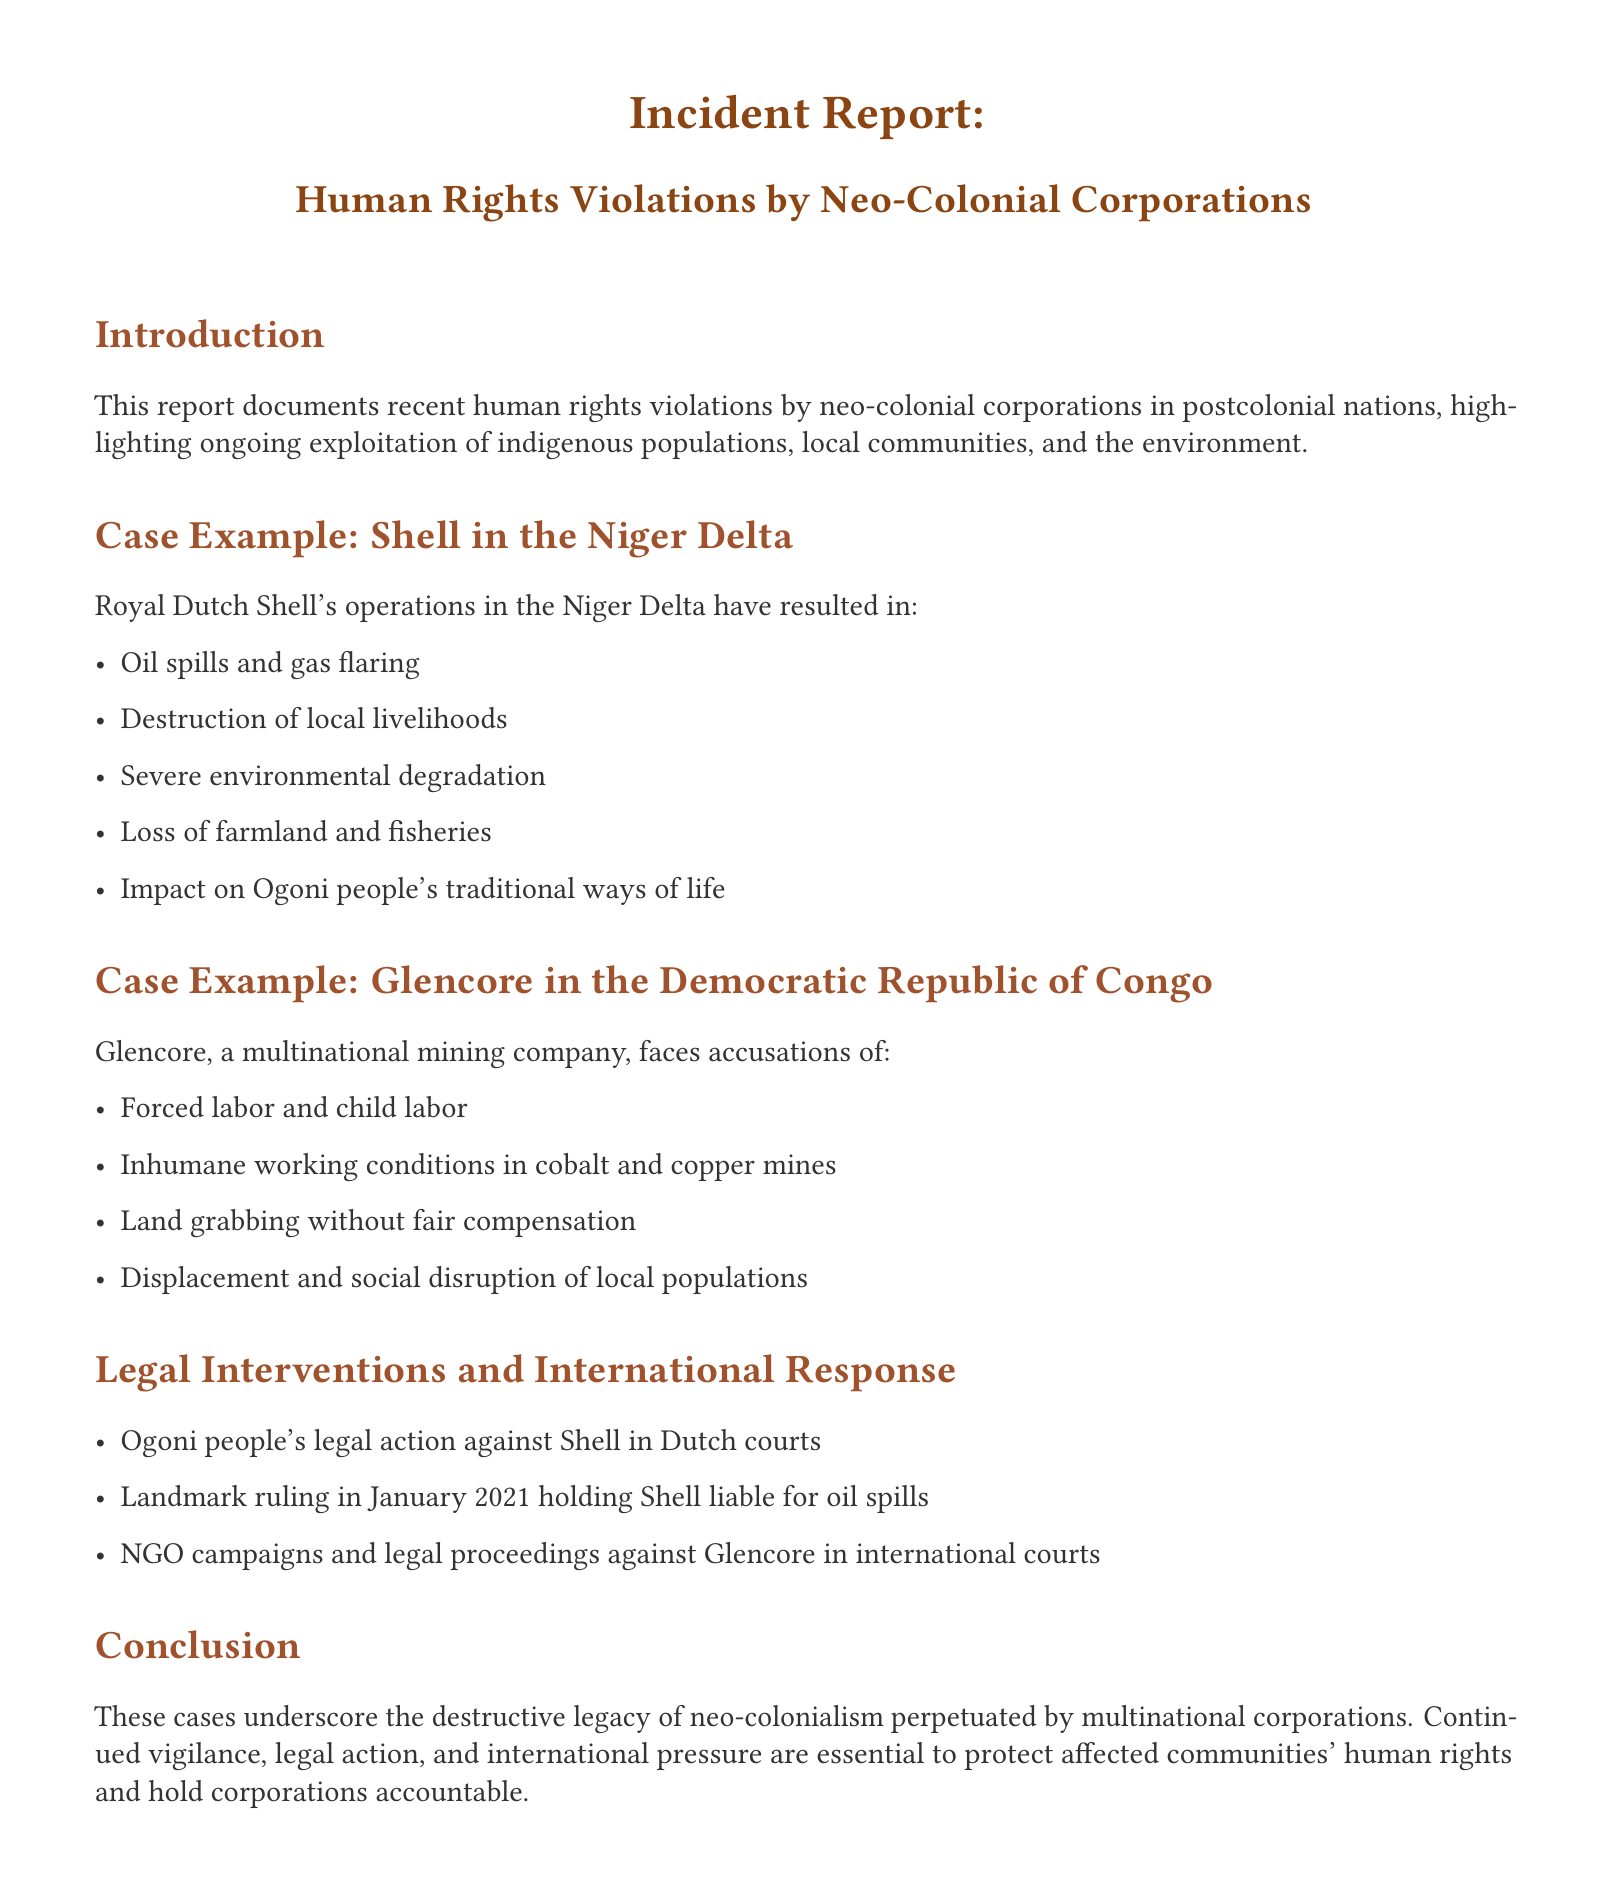What is the first case example mentioned? The document discusses incidents involving Shell in the Niger Delta as the first case example.
Answer: Shell in the Niger Delta What type of violations does Glencore face in the Democratic Republic of Congo? The document states that Glencore faces accusations of forced labor and child labor among other violations.
Answer: Forced labor and child labor What is the legal action taken by the Ogoni people against Shell? The legal intervention mentioned in the document involves Ogoni people's action against Shell in Dutch courts.
Answer: Legal action in Dutch courts In what year was the landmark ruling that held Shell liable for oil spills? The document specifies that the landmark ruling occurred in January 2021.
Answer: January 2021 What is one of the environmental impacts mentioned regarding Shell's operations? The document highlights severe environmental degradation as one of the impacts from Shell's operations.
Answer: Severe environmental degradation What concept does the conclusion of the report emphasize? The conclusion underlines the destructive legacy of neo-colonialism perpetuated by multinational corporations.
Answer: Destructive legacy of neo-colonialism What method is highlighted for holding corporations accountable? The report mentions continued vigilance and legal action as essential methods for accountability in affected communities.
Answer: Legal action What is the main focus of this incident report? The primary focus of the document is on human rights violations by neo-colonial corporations.
Answer: Human rights violations by neo-colonial corporations 